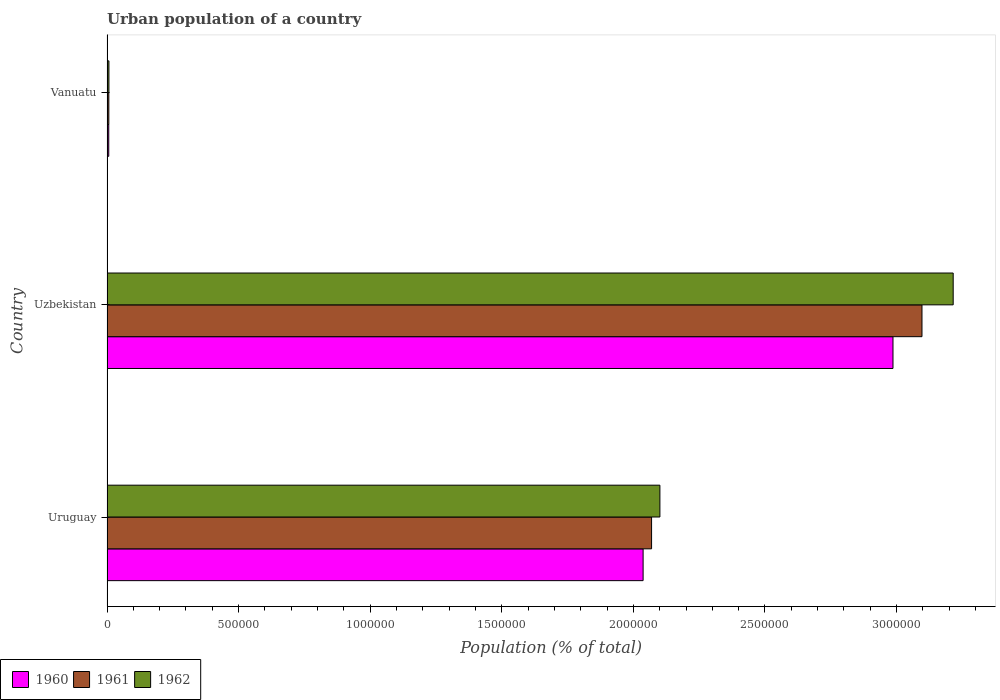How many different coloured bars are there?
Give a very brief answer. 3. How many groups of bars are there?
Your answer should be compact. 3. Are the number of bars per tick equal to the number of legend labels?
Your response must be concise. Yes. How many bars are there on the 2nd tick from the top?
Give a very brief answer. 3. What is the label of the 1st group of bars from the top?
Keep it short and to the point. Vanuatu. What is the urban population in 1961 in Vanuatu?
Your response must be concise. 6954. Across all countries, what is the maximum urban population in 1960?
Offer a very short reply. 2.99e+06. Across all countries, what is the minimum urban population in 1962?
Make the answer very short. 7299. In which country was the urban population in 1960 maximum?
Offer a terse response. Uzbekistan. In which country was the urban population in 1962 minimum?
Your response must be concise. Vanuatu. What is the total urban population in 1961 in the graph?
Offer a terse response. 5.17e+06. What is the difference between the urban population in 1962 in Uruguay and that in Vanuatu?
Provide a short and direct response. 2.09e+06. What is the difference between the urban population in 1962 in Uzbekistan and the urban population in 1960 in Vanuatu?
Keep it short and to the point. 3.21e+06. What is the average urban population in 1962 per country?
Your answer should be compact. 1.77e+06. What is the difference between the urban population in 1961 and urban population in 1960 in Uruguay?
Your answer should be compact. 3.22e+04. In how many countries, is the urban population in 1962 greater than 1600000 %?
Make the answer very short. 2. What is the ratio of the urban population in 1962 in Uruguay to that in Uzbekistan?
Offer a very short reply. 0.65. What is the difference between the highest and the second highest urban population in 1961?
Offer a terse response. 1.03e+06. What is the difference between the highest and the lowest urban population in 1962?
Your answer should be very brief. 3.21e+06. Is the sum of the urban population in 1962 in Uruguay and Uzbekistan greater than the maximum urban population in 1960 across all countries?
Offer a very short reply. Yes. Is it the case that in every country, the sum of the urban population in 1961 and urban population in 1962 is greater than the urban population in 1960?
Your answer should be compact. Yes. How many bars are there?
Provide a short and direct response. 9. Where does the legend appear in the graph?
Make the answer very short. Bottom left. What is the title of the graph?
Ensure brevity in your answer.  Urban population of a country. Does "2002" appear as one of the legend labels in the graph?
Offer a very short reply. No. What is the label or title of the X-axis?
Your answer should be compact. Population (% of total). What is the label or title of the Y-axis?
Ensure brevity in your answer.  Country. What is the Population (% of total) of 1960 in Uruguay?
Provide a succinct answer. 2.04e+06. What is the Population (% of total) of 1961 in Uruguay?
Offer a terse response. 2.07e+06. What is the Population (% of total) in 1962 in Uruguay?
Make the answer very short. 2.10e+06. What is the Population (% of total) of 1960 in Uzbekistan?
Your answer should be compact. 2.99e+06. What is the Population (% of total) in 1961 in Uzbekistan?
Provide a succinct answer. 3.10e+06. What is the Population (% of total) of 1962 in Uzbekistan?
Offer a terse response. 3.22e+06. What is the Population (% of total) of 1960 in Vanuatu?
Offer a terse response. 6627. What is the Population (% of total) in 1961 in Vanuatu?
Give a very brief answer. 6954. What is the Population (% of total) in 1962 in Vanuatu?
Your response must be concise. 7299. Across all countries, what is the maximum Population (% of total) in 1960?
Provide a short and direct response. 2.99e+06. Across all countries, what is the maximum Population (% of total) in 1961?
Make the answer very short. 3.10e+06. Across all countries, what is the maximum Population (% of total) of 1962?
Offer a terse response. 3.22e+06. Across all countries, what is the minimum Population (% of total) of 1960?
Make the answer very short. 6627. Across all countries, what is the minimum Population (% of total) in 1961?
Give a very brief answer. 6954. Across all countries, what is the minimum Population (% of total) in 1962?
Your response must be concise. 7299. What is the total Population (% of total) of 1960 in the graph?
Offer a very short reply. 5.03e+06. What is the total Population (% of total) in 1961 in the graph?
Provide a short and direct response. 5.17e+06. What is the total Population (% of total) in 1962 in the graph?
Your response must be concise. 5.32e+06. What is the difference between the Population (% of total) in 1960 in Uruguay and that in Uzbekistan?
Your answer should be very brief. -9.49e+05. What is the difference between the Population (% of total) of 1961 in Uruguay and that in Uzbekistan?
Offer a very short reply. -1.03e+06. What is the difference between the Population (% of total) in 1962 in Uruguay and that in Uzbekistan?
Provide a succinct answer. -1.11e+06. What is the difference between the Population (% of total) in 1960 in Uruguay and that in Vanuatu?
Your answer should be compact. 2.03e+06. What is the difference between the Population (% of total) in 1961 in Uruguay and that in Vanuatu?
Provide a short and direct response. 2.06e+06. What is the difference between the Population (% of total) in 1962 in Uruguay and that in Vanuatu?
Keep it short and to the point. 2.09e+06. What is the difference between the Population (% of total) in 1960 in Uzbekistan and that in Vanuatu?
Your response must be concise. 2.98e+06. What is the difference between the Population (% of total) in 1961 in Uzbekistan and that in Vanuatu?
Your answer should be very brief. 3.09e+06. What is the difference between the Population (% of total) in 1962 in Uzbekistan and that in Vanuatu?
Offer a very short reply. 3.21e+06. What is the difference between the Population (% of total) of 1960 in Uruguay and the Population (% of total) of 1961 in Uzbekistan?
Provide a succinct answer. -1.06e+06. What is the difference between the Population (% of total) of 1960 in Uruguay and the Population (% of total) of 1962 in Uzbekistan?
Ensure brevity in your answer.  -1.18e+06. What is the difference between the Population (% of total) of 1961 in Uruguay and the Population (% of total) of 1962 in Uzbekistan?
Keep it short and to the point. -1.15e+06. What is the difference between the Population (% of total) of 1960 in Uruguay and the Population (% of total) of 1961 in Vanuatu?
Ensure brevity in your answer.  2.03e+06. What is the difference between the Population (% of total) of 1960 in Uruguay and the Population (% of total) of 1962 in Vanuatu?
Offer a terse response. 2.03e+06. What is the difference between the Population (% of total) in 1961 in Uruguay and the Population (% of total) in 1962 in Vanuatu?
Your answer should be compact. 2.06e+06. What is the difference between the Population (% of total) of 1960 in Uzbekistan and the Population (% of total) of 1961 in Vanuatu?
Your response must be concise. 2.98e+06. What is the difference between the Population (% of total) in 1960 in Uzbekistan and the Population (% of total) in 1962 in Vanuatu?
Provide a succinct answer. 2.98e+06. What is the difference between the Population (% of total) of 1961 in Uzbekistan and the Population (% of total) of 1962 in Vanuatu?
Offer a very short reply. 3.09e+06. What is the average Population (% of total) of 1960 per country?
Your answer should be very brief. 1.68e+06. What is the average Population (% of total) of 1961 per country?
Your answer should be compact. 1.72e+06. What is the average Population (% of total) of 1962 per country?
Keep it short and to the point. 1.77e+06. What is the difference between the Population (% of total) of 1960 and Population (% of total) of 1961 in Uruguay?
Provide a succinct answer. -3.22e+04. What is the difference between the Population (% of total) in 1960 and Population (% of total) in 1962 in Uruguay?
Keep it short and to the point. -6.38e+04. What is the difference between the Population (% of total) of 1961 and Population (% of total) of 1962 in Uruguay?
Offer a very short reply. -3.16e+04. What is the difference between the Population (% of total) in 1960 and Population (% of total) in 1961 in Uzbekistan?
Provide a short and direct response. -1.10e+05. What is the difference between the Population (% of total) in 1960 and Population (% of total) in 1962 in Uzbekistan?
Give a very brief answer. -2.29e+05. What is the difference between the Population (% of total) of 1961 and Population (% of total) of 1962 in Uzbekistan?
Your response must be concise. -1.19e+05. What is the difference between the Population (% of total) in 1960 and Population (% of total) in 1961 in Vanuatu?
Your answer should be compact. -327. What is the difference between the Population (% of total) of 1960 and Population (% of total) of 1962 in Vanuatu?
Your answer should be compact. -672. What is the difference between the Population (% of total) of 1961 and Population (% of total) of 1962 in Vanuatu?
Your answer should be very brief. -345. What is the ratio of the Population (% of total) in 1960 in Uruguay to that in Uzbekistan?
Offer a terse response. 0.68. What is the ratio of the Population (% of total) in 1961 in Uruguay to that in Uzbekistan?
Your answer should be compact. 0.67. What is the ratio of the Population (% of total) of 1962 in Uruguay to that in Uzbekistan?
Your response must be concise. 0.65. What is the ratio of the Population (% of total) in 1960 in Uruguay to that in Vanuatu?
Ensure brevity in your answer.  307.38. What is the ratio of the Population (% of total) of 1961 in Uruguay to that in Vanuatu?
Offer a very short reply. 297.56. What is the ratio of the Population (% of total) in 1962 in Uruguay to that in Vanuatu?
Offer a terse response. 287.83. What is the ratio of the Population (% of total) in 1960 in Uzbekistan to that in Vanuatu?
Keep it short and to the point. 450.66. What is the ratio of the Population (% of total) of 1961 in Uzbekistan to that in Vanuatu?
Provide a succinct answer. 445.31. What is the ratio of the Population (% of total) of 1962 in Uzbekistan to that in Vanuatu?
Offer a very short reply. 440.5. What is the difference between the highest and the second highest Population (% of total) in 1960?
Your answer should be compact. 9.49e+05. What is the difference between the highest and the second highest Population (% of total) in 1961?
Your response must be concise. 1.03e+06. What is the difference between the highest and the second highest Population (% of total) in 1962?
Make the answer very short. 1.11e+06. What is the difference between the highest and the lowest Population (% of total) in 1960?
Keep it short and to the point. 2.98e+06. What is the difference between the highest and the lowest Population (% of total) in 1961?
Offer a very short reply. 3.09e+06. What is the difference between the highest and the lowest Population (% of total) of 1962?
Offer a very short reply. 3.21e+06. 